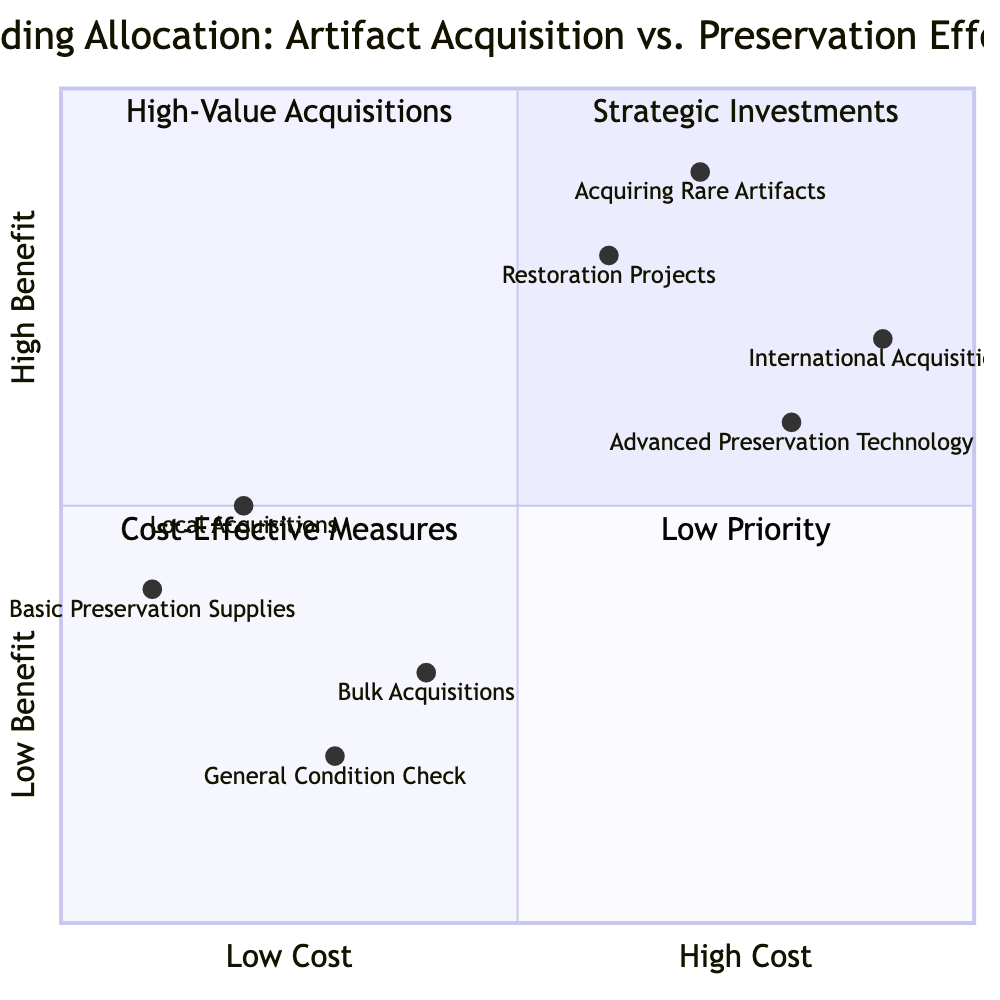What artifacts are placed in the High Benefit quadrant? The High Benefit quadrant contains "Acquiring Rare Artifacts" and "Restoration Projects," which both contribute significantly to the value of the collection.
Answer: Acquiring Rare Artifacts, Restoration Projects What is located in the Low Cost quadrant? The Low Cost quadrant includes "Local Acquisitions" and "Basic Preservation Supplies," representing cost-effective options for funding allocation.
Answer: Local Acquisitions, Basic Preservation Supplies Which artifacts are considered Low Benefit? The Low Benefit quadrant features "Bulk Acquisitions" and "General Condition Check," indicating that these efforts do not greatly enhance value or longevity.
Answer: Bulk Acquisitions, General Condition Check How many elements are there in the High Cost quadrant? The High Cost quadrant has two elements: "International Acquisitions" and "Advanced Preservation Technology."
Answer: 2 What is the relationship between Restoration Projects and International Acquisitions? "Restoration Projects" (High Benefit) is focused on improving existing items, while "International Acquisitions" (High Cost) focuses on acquiring new, often expensive items, indicating a strategic balance between preservation and acquisition efforts.
Answer: Restoration Projects enhances value; International Acquisitions increases costs Which artifact has the highest perceived cost in this chart? "International Acquisitions" is positioned high on the cost scale, demonstrating it is seen as a significant financial investment compared to others.
Answer: International Acquisitions What is the main focus of the Low Priority quadrant? The Low Priority quadrant is represented by "Bulk Acquisitions" and "General Condition Check," suggesting these activities are seen as less critical to the overall collection strategy.
Answer: Bulk Acquisitions, General Condition Check Which category contains efforts with both high costs and high benefits? The quadrant that combines both high costs and high benefits includes elements like "Acquiring Rare Artifacts" and "Restoration Projects," showcasing investments that yield significant value.
Answer: Acquiring Rare Artifacts, Restoration Projects 